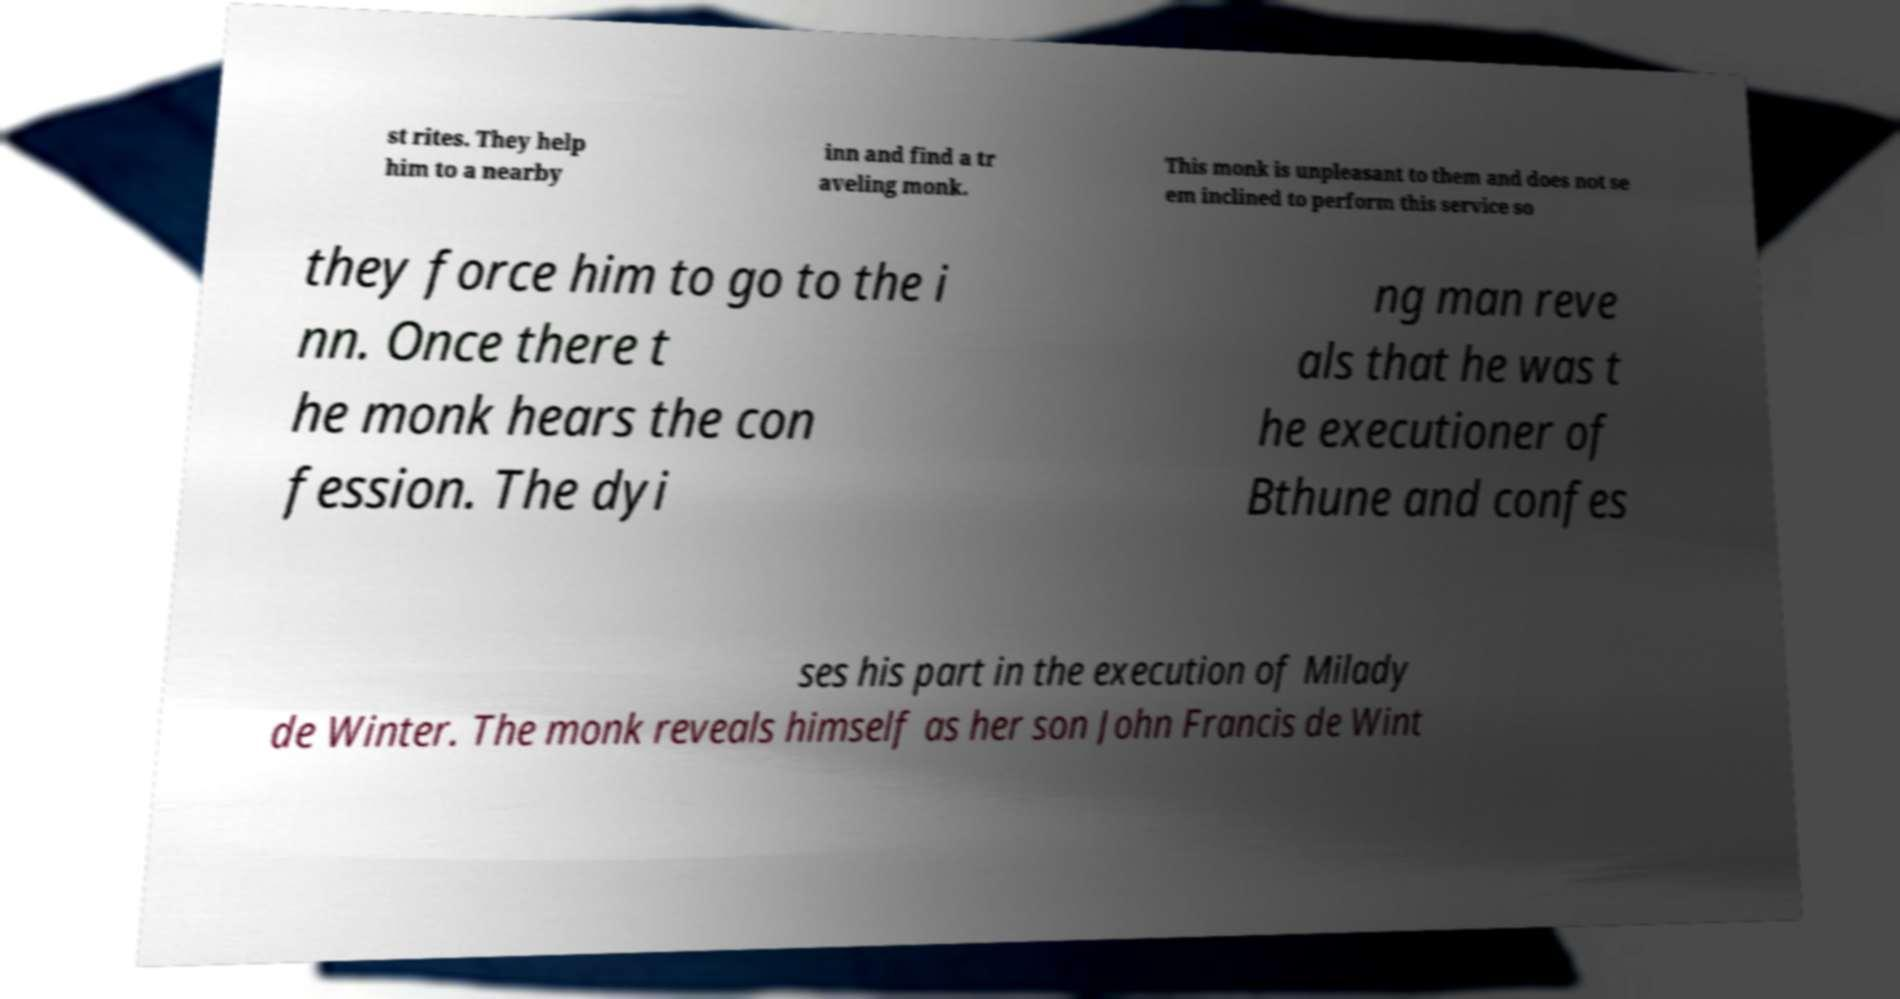Could you extract and type out the text from this image? st rites. They help him to a nearby inn and find a tr aveling monk. This monk is unpleasant to them and does not se em inclined to perform this service so they force him to go to the i nn. Once there t he monk hears the con fession. The dyi ng man reve als that he was t he executioner of Bthune and confes ses his part in the execution of Milady de Winter. The monk reveals himself as her son John Francis de Wint 